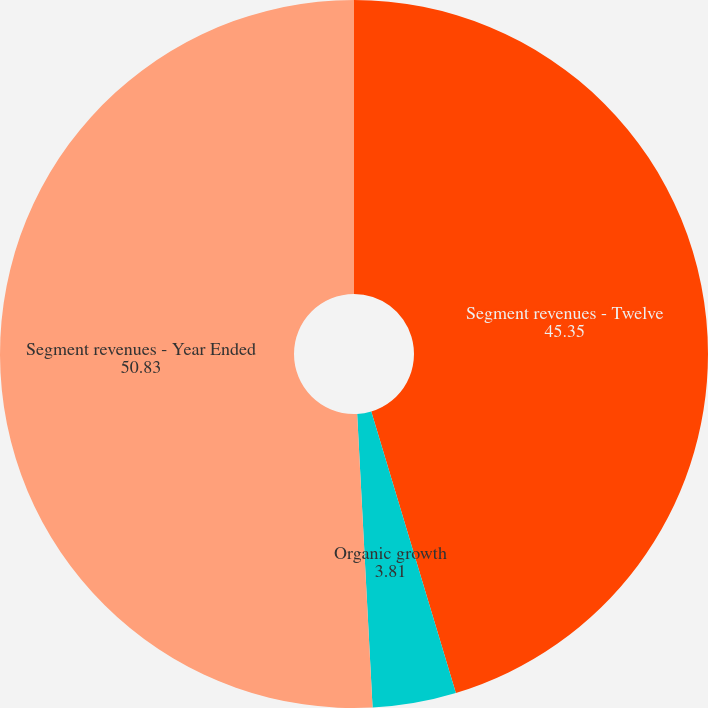<chart> <loc_0><loc_0><loc_500><loc_500><pie_chart><fcel>Segment revenues - Twelve<fcel>Organic growth<fcel>Segment revenues - Year Ended<nl><fcel>45.35%<fcel>3.81%<fcel>50.83%<nl></chart> 